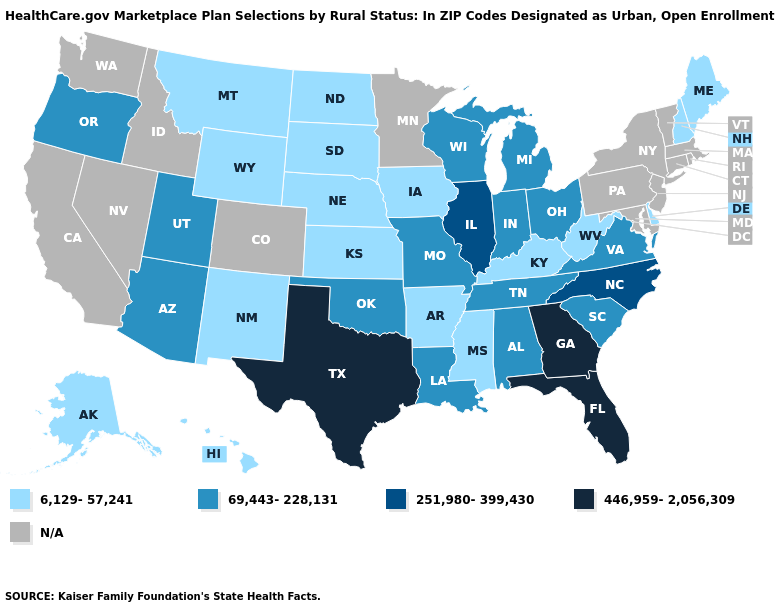What is the value of Oregon?
Write a very short answer. 69,443-228,131. Name the states that have a value in the range 251,980-399,430?
Be succinct. Illinois, North Carolina. What is the value of New Mexico?
Keep it brief. 6,129-57,241. Does Wyoming have the lowest value in the West?
Be succinct. Yes. What is the lowest value in the Northeast?
Quick response, please. 6,129-57,241. Among the states that border Nebraska , which have the lowest value?
Answer briefly. Iowa, Kansas, South Dakota, Wyoming. What is the highest value in the MidWest ?
Be succinct. 251,980-399,430. Which states have the lowest value in the USA?
Quick response, please. Alaska, Arkansas, Delaware, Hawaii, Iowa, Kansas, Kentucky, Maine, Mississippi, Montana, Nebraska, New Hampshire, New Mexico, North Dakota, South Dakota, West Virginia, Wyoming. What is the value of Arkansas?
Quick response, please. 6,129-57,241. What is the value of Ohio?
Concise answer only. 69,443-228,131. Is the legend a continuous bar?
Write a very short answer. No. 